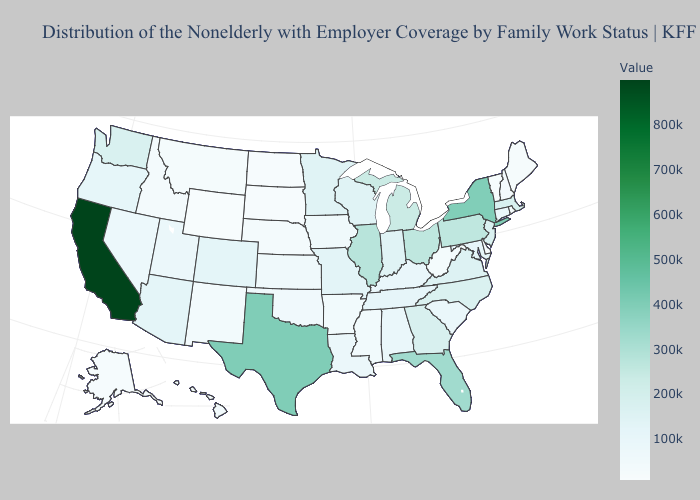Is the legend a continuous bar?
Be succinct. Yes. Does Oklahoma have the highest value in the South?
Quick response, please. No. Which states have the lowest value in the West?
Quick response, please. Wyoming. Is the legend a continuous bar?
Be succinct. Yes. Does Alaska have a lower value than Minnesota?
Keep it brief. Yes. Among the states that border Florida , which have the highest value?
Answer briefly. Georgia. Which states have the lowest value in the USA?
Quick response, please. Wyoming. Does New Jersey have the highest value in the Northeast?
Keep it brief. No. 